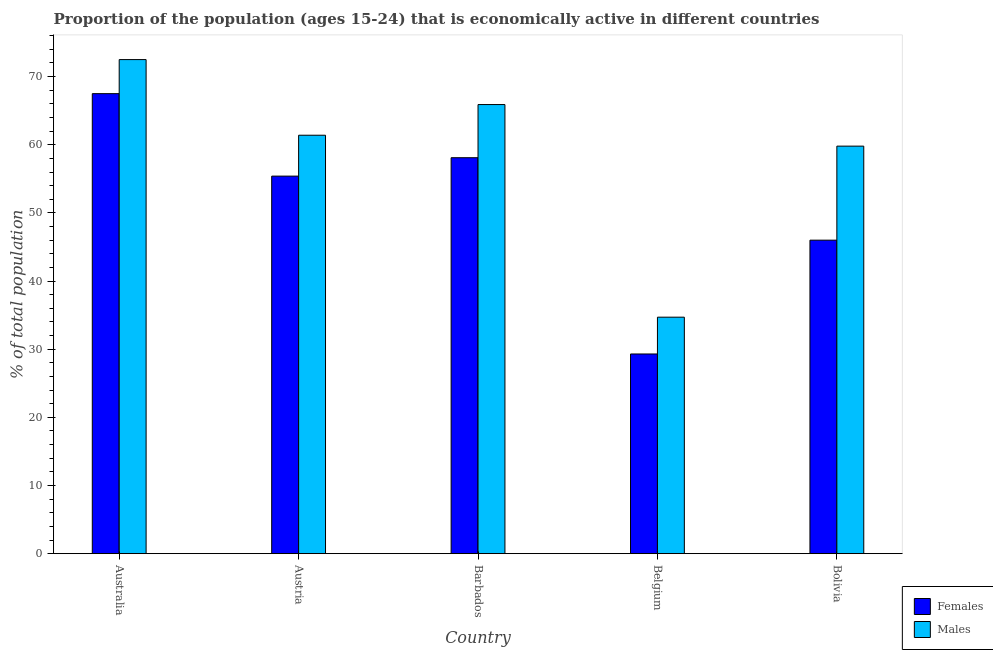How many different coloured bars are there?
Provide a succinct answer. 2. How many groups of bars are there?
Give a very brief answer. 5. Are the number of bars per tick equal to the number of legend labels?
Make the answer very short. Yes. Are the number of bars on each tick of the X-axis equal?
Keep it short and to the point. Yes. What is the percentage of economically active female population in Australia?
Your response must be concise. 67.5. Across all countries, what is the maximum percentage of economically active male population?
Give a very brief answer. 72.5. Across all countries, what is the minimum percentage of economically active female population?
Offer a terse response. 29.3. What is the total percentage of economically active female population in the graph?
Offer a very short reply. 256.3. What is the difference between the percentage of economically active male population in Australia and that in Bolivia?
Keep it short and to the point. 12.7. What is the difference between the percentage of economically active male population in Bolivia and the percentage of economically active female population in Austria?
Ensure brevity in your answer.  4.4. What is the average percentage of economically active male population per country?
Ensure brevity in your answer.  58.86. What is the difference between the percentage of economically active female population and percentage of economically active male population in Bolivia?
Give a very brief answer. -13.8. In how many countries, is the percentage of economically active male population greater than 32 %?
Your answer should be compact. 5. What is the ratio of the percentage of economically active male population in Austria to that in Belgium?
Provide a short and direct response. 1.77. Is the percentage of economically active female population in Australia less than that in Bolivia?
Your response must be concise. No. What is the difference between the highest and the second highest percentage of economically active male population?
Provide a succinct answer. 6.6. What is the difference between the highest and the lowest percentage of economically active female population?
Make the answer very short. 38.2. In how many countries, is the percentage of economically active male population greater than the average percentage of economically active male population taken over all countries?
Keep it short and to the point. 4. What does the 2nd bar from the left in Bolivia represents?
Your response must be concise. Males. What does the 1st bar from the right in Australia represents?
Keep it short and to the point. Males. What is the difference between two consecutive major ticks on the Y-axis?
Your answer should be very brief. 10. Are the values on the major ticks of Y-axis written in scientific E-notation?
Your answer should be very brief. No. Does the graph contain any zero values?
Your answer should be compact. No. How are the legend labels stacked?
Provide a short and direct response. Vertical. What is the title of the graph?
Offer a terse response. Proportion of the population (ages 15-24) that is economically active in different countries. What is the label or title of the X-axis?
Make the answer very short. Country. What is the label or title of the Y-axis?
Offer a very short reply. % of total population. What is the % of total population of Females in Australia?
Give a very brief answer. 67.5. What is the % of total population in Males in Australia?
Provide a short and direct response. 72.5. What is the % of total population in Females in Austria?
Offer a very short reply. 55.4. What is the % of total population in Males in Austria?
Offer a very short reply. 61.4. What is the % of total population of Females in Barbados?
Provide a short and direct response. 58.1. What is the % of total population of Males in Barbados?
Provide a short and direct response. 65.9. What is the % of total population in Females in Belgium?
Make the answer very short. 29.3. What is the % of total population in Males in Belgium?
Your answer should be very brief. 34.7. What is the % of total population of Females in Bolivia?
Give a very brief answer. 46. What is the % of total population in Males in Bolivia?
Provide a succinct answer. 59.8. Across all countries, what is the maximum % of total population of Females?
Give a very brief answer. 67.5. Across all countries, what is the maximum % of total population in Males?
Give a very brief answer. 72.5. Across all countries, what is the minimum % of total population of Females?
Your response must be concise. 29.3. Across all countries, what is the minimum % of total population of Males?
Your answer should be compact. 34.7. What is the total % of total population of Females in the graph?
Offer a terse response. 256.3. What is the total % of total population of Males in the graph?
Ensure brevity in your answer.  294.3. What is the difference between the % of total population of Females in Australia and that in Austria?
Ensure brevity in your answer.  12.1. What is the difference between the % of total population of Males in Australia and that in Austria?
Provide a short and direct response. 11.1. What is the difference between the % of total population of Females in Australia and that in Barbados?
Give a very brief answer. 9.4. What is the difference between the % of total population of Males in Australia and that in Barbados?
Provide a succinct answer. 6.6. What is the difference between the % of total population of Females in Australia and that in Belgium?
Your response must be concise. 38.2. What is the difference between the % of total population of Males in Australia and that in Belgium?
Give a very brief answer. 37.8. What is the difference between the % of total population of Males in Austria and that in Barbados?
Provide a succinct answer. -4.5. What is the difference between the % of total population of Females in Austria and that in Belgium?
Offer a very short reply. 26.1. What is the difference between the % of total population in Males in Austria and that in Belgium?
Provide a succinct answer. 26.7. What is the difference between the % of total population in Females in Barbados and that in Belgium?
Make the answer very short. 28.8. What is the difference between the % of total population in Males in Barbados and that in Belgium?
Give a very brief answer. 31.2. What is the difference between the % of total population of Males in Barbados and that in Bolivia?
Offer a terse response. 6.1. What is the difference between the % of total population in Females in Belgium and that in Bolivia?
Offer a very short reply. -16.7. What is the difference between the % of total population in Males in Belgium and that in Bolivia?
Your answer should be compact. -25.1. What is the difference between the % of total population of Females in Australia and the % of total population of Males in Austria?
Keep it short and to the point. 6.1. What is the difference between the % of total population in Females in Australia and the % of total population in Males in Belgium?
Your response must be concise. 32.8. What is the difference between the % of total population in Females in Australia and the % of total population in Males in Bolivia?
Offer a terse response. 7.7. What is the difference between the % of total population of Females in Austria and the % of total population of Males in Barbados?
Provide a succinct answer. -10.5. What is the difference between the % of total population in Females in Austria and the % of total population in Males in Belgium?
Provide a succinct answer. 20.7. What is the difference between the % of total population of Females in Austria and the % of total population of Males in Bolivia?
Keep it short and to the point. -4.4. What is the difference between the % of total population of Females in Barbados and the % of total population of Males in Belgium?
Ensure brevity in your answer.  23.4. What is the difference between the % of total population of Females in Barbados and the % of total population of Males in Bolivia?
Provide a succinct answer. -1.7. What is the difference between the % of total population in Females in Belgium and the % of total population in Males in Bolivia?
Your response must be concise. -30.5. What is the average % of total population of Females per country?
Make the answer very short. 51.26. What is the average % of total population in Males per country?
Provide a succinct answer. 58.86. What is the difference between the % of total population of Females and % of total population of Males in Australia?
Offer a very short reply. -5. What is the difference between the % of total population of Females and % of total population of Males in Barbados?
Provide a short and direct response. -7.8. What is the difference between the % of total population in Females and % of total population in Males in Belgium?
Offer a very short reply. -5.4. What is the ratio of the % of total population in Females in Australia to that in Austria?
Give a very brief answer. 1.22. What is the ratio of the % of total population of Males in Australia to that in Austria?
Keep it short and to the point. 1.18. What is the ratio of the % of total population of Females in Australia to that in Barbados?
Keep it short and to the point. 1.16. What is the ratio of the % of total population of Males in Australia to that in Barbados?
Your answer should be very brief. 1.1. What is the ratio of the % of total population in Females in Australia to that in Belgium?
Your response must be concise. 2.3. What is the ratio of the % of total population of Males in Australia to that in Belgium?
Offer a terse response. 2.09. What is the ratio of the % of total population of Females in Australia to that in Bolivia?
Make the answer very short. 1.47. What is the ratio of the % of total population in Males in Australia to that in Bolivia?
Your answer should be compact. 1.21. What is the ratio of the % of total population in Females in Austria to that in Barbados?
Your answer should be very brief. 0.95. What is the ratio of the % of total population in Males in Austria to that in Barbados?
Your response must be concise. 0.93. What is the ratio of the % of total population of Females in Austria to that in Belgium?
Your answer should be very brief. 1.89. What is the ratio of the % of total population of Males in Austria to that in Belgium?
Give a very brief answer. 1.77. What is the ratio of the % of total population of Females in Austria to that in Bolivia?
Ensure brevity in your answer.  1.2. What is the ratio of the % of total population in Males in Austria to that in Bolivia?
Offer a very short reply. 1.03. What is the ratio of the % of total population in Females in Barbados to that in Belgium?
Ensure brevity in your answer.  1.98. What is the ratio of the % of total population in Males in Barbados to that in Belgium?
Offer a very short reply. 1.9. What is the ratio of the % of total population in Females in Barbados to that in Bolivia?
Your response must be concise. 1.26. What is the ratio of the % of total population of Males in Barbados to that in Bolivia?
Provide a succinct answer. 1.1. What is the ratio of the % of total population of Females in Belgium to that in Bolivia?
Keep it short and to the point. 0.64. What is the ratio of the % of total population of Males in Belgium to that in Bolivia?
Offer a very short reply. 0.58. What is the difference between the highest and the second highest % of total population of Females?
Keep it short and to the point. 9.4. What is the difference between the highest and the lowest % of total population of Females?
Give a very brief answer. 38.2. What is the difference between the highest and the lowest % of total population in Males?
Give a very brief answer. 37.8. 